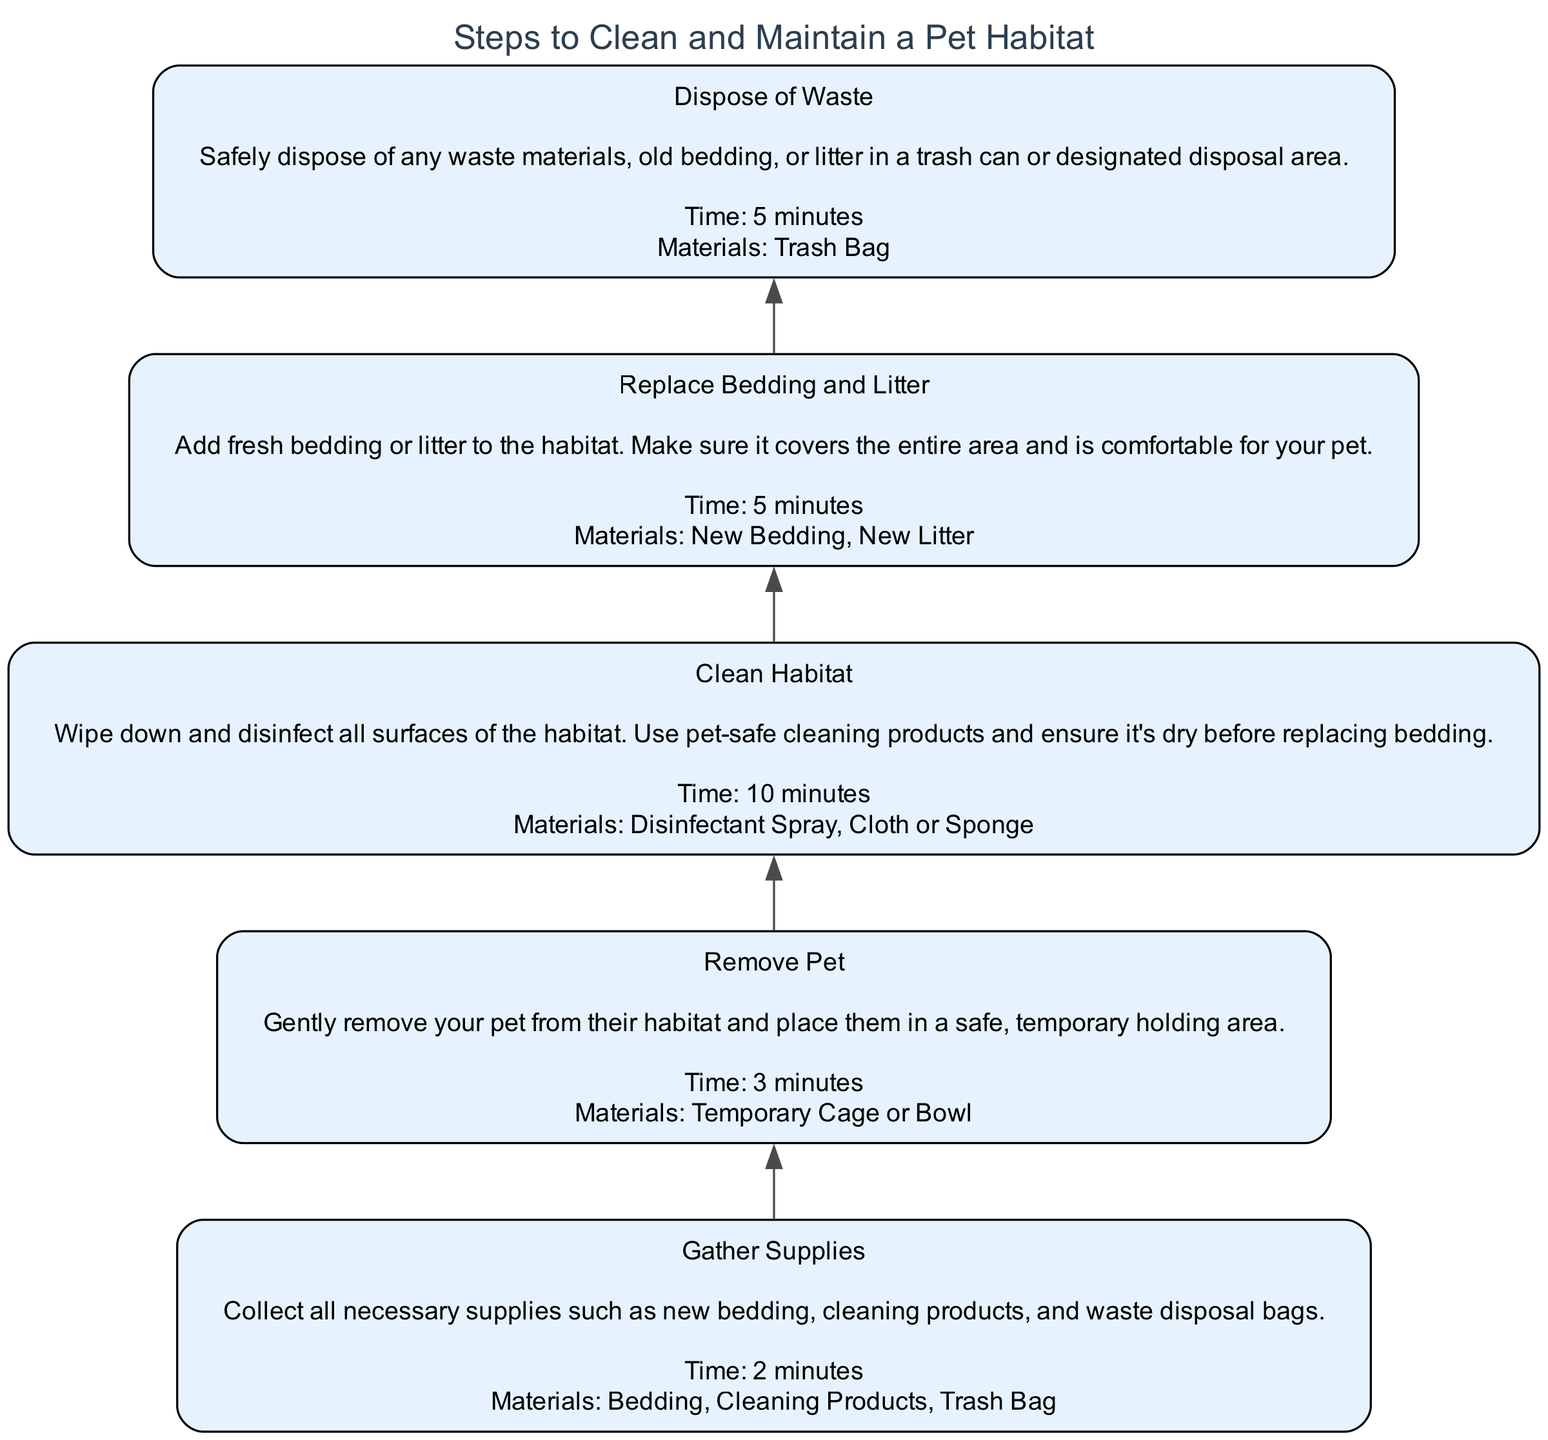What is the first step to clean a pet habitat? The first step listed in the diagram is "Gather Supplies," which involves collecting all necessary supplies such as new bedding, cleaning products, and waste disposal bags.
Answer: Gather Supplies How long does it take to replace bedding and litter? The diagram states that replacing bedding and litter takes 5 minutes according to the metrics provided for that step.
Answer: 5 minutes What materials are needed for cleaning the habitat? In the "Clean Habitat" step, the materials needed include "Disinfectant Spray" and "Cloth or Sponge," as specified in the metrics of that step.
Answer: Disinfectant Spray, Cloth or Sponge What is the last step in the flowchart? The last step depicted in the flowchart is "Dispose of Waste," which is the final action taken to maintain a clean pet habitat as shown in the upward flow of the steps.
Answer: Dispose of Waste How many steps are in the diagram? By counting the steps shown in the flowchart, we find there are a total of five steps involved in cleaning and maintaining a pet habitat.
Answer: 5 Before which step do you remove the pet? The "Remove Pet" step must be completed before you can proceed to "Clean Habitat," establishing the order of operations that ensures pet safety during cleaning.
Answer: Clean Habitat What is the sequence of actions starting from gathering supplies to disposing of waste? The sequence is: 1) Gather Supplies, 2) Remove Pet, 3) Clean Habitat, 4) Replace Bedding and Litter, 5) Dispose of Waste. This shows the order in which tasks should be performed according to the flowchart.
Answer: Gather Supplies, Remove Pet, Clean Habitat, Replace Bedding and Litter, Dispose of Waste What does each step lead to in the flowchart? Each step leads to the subsequent step, meaning "Gather Supplies" leads to "Remove Pet," "Remove Pet" leads to "Clean Habitat," and so on, illustrating a clear progression from one task to the next.
Answer: Sequentially to the next step What should be done after cleaning the habitat? After cleaning the habitat, the next action is to "Replace Bedding and Litter" as indicated by the flowchart, highlighting the necessary follow-up task directly after cleaning.
Answer: Replace Bedding and Litter 